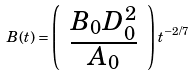Convert formula to latex. <formula><loc_0><loc_0><loc_500><loc_500>B ( t ) = \left ( \begin{array} { c } \frac { B _ { 0 } D _ { 0 } ^ { 2 } } { A _ { 0 } } \end{array} \right ) t ^ { - 2 / 7 }</formula> 